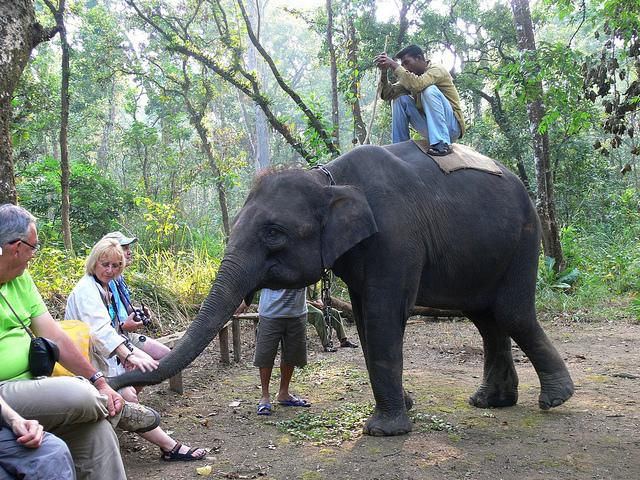What other animal is this animal traditionally afraid of? mice 